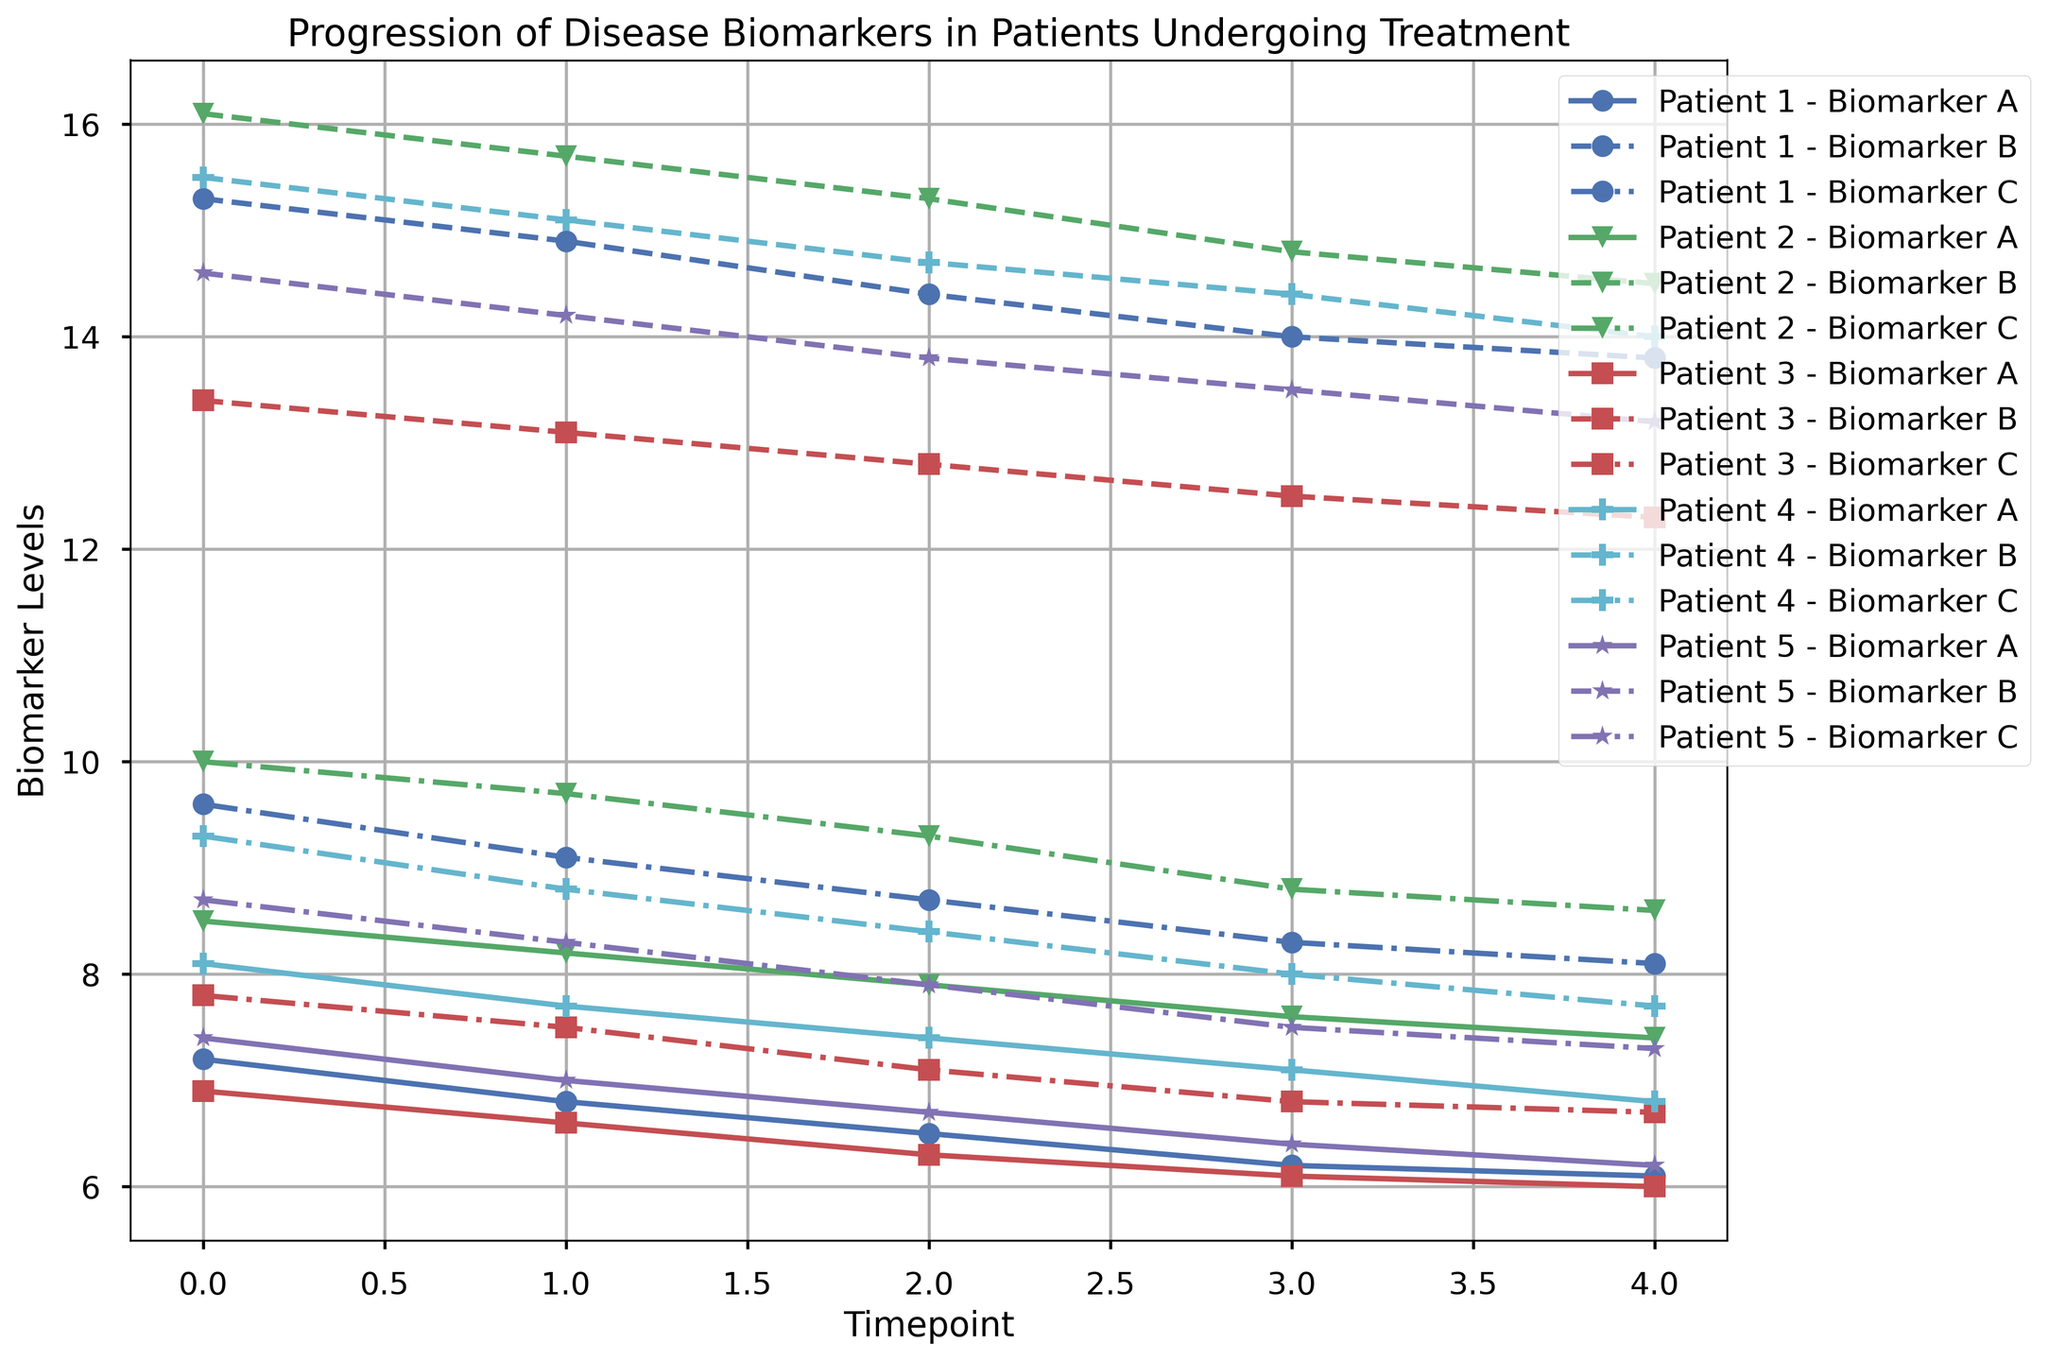What is the general trend of biomarker A for patient 1 from timepoint 0 to timepoint 4? When examining the provided plot, the biomarker A levels for patient 1 show a steady decrease over time from timepoint 0 to timepoint 4.
Answer: Decreasing Which biomarkers are noted with dashed lines and which with dash-dot lines for any given patient? Reviewing the plot legend reveals various line styles: dashed lines represent changes in biomarker B, whereas dash-dot lines indicate variations in biomarker C.
Answer: Biomarker B (dashed), Biomarker C (dash-dot) Who among the patients shows the steepest decline in biomarker C between timepoints 0 to 4? By comparing the slopes of the dash-dot lines corresponding to biomarker C for all patients, patient 3 stands out with the sharpest downward trajectory from timepoint 0 to timepoint 4.
Answer: Patient 3 At timepoint 4, which patient demonstrates the highest biomarker A level? Inspecting all the marker points for biomarker A at timepoint 4, patient 2 has the highest recorded level among all.
Answer: Patient 2 Between patient 2 and patient 4, whose biomarker B level is higher at timepoint 2? Comparing the two dashed lines corresponding to patient 2 and patient 4 at timepoint 2, it is clear that patient 2 has a higher biomarker B value at that instant.
Answer: Patient 2 Calculate the average value of biomarker A for patient 5 over all the timepoints. The biomarker A values for patient 5 across the timepoints are 7.4, 7.0, 6.7, 6.4, and 6.2. Their sum is 33.7. The average is then 33.7/5, yielding an average value of 6.74.
Answer: 6.74 Which patient's biomarker values appear most stable (least variability) for biomarker C across all timepoints? Stability can be inferred by observing the least fluctuation in the dash-dot lines representing each patient's biomarker C. Patient 5’s biomarker C shows minimal variability.
Answer: Patient 5 If reviewing the highest overall level for any biomarker at timepoint 0, which biomarker and which patient are involved? From the plot annotations, at timepoint 0, the highest level is for biomarker B and it is exhibited by patient 2.
Answer: Biomarker B, Patient 2 At timepoint 1, determine if patient 3's biomarker A level is closer to patient 1's or patient 4's biomarker A level? Comparing patient 3's biomarker A level at timepoint 1 (6.6) with patient 1's (6.8) and patient 4's (7.7), patient 3's level of 6.6 is numerically closer to patient 1's 6.8.
Answer: Patient 1 Which patient has consistently higher biomarker A levels than patient 3 at each timepoint? By evaluating the biomarker A levels throughout all timepoints, patient 4 maintains higher values than patient 3 in each instance.
Answer: Patient 4 